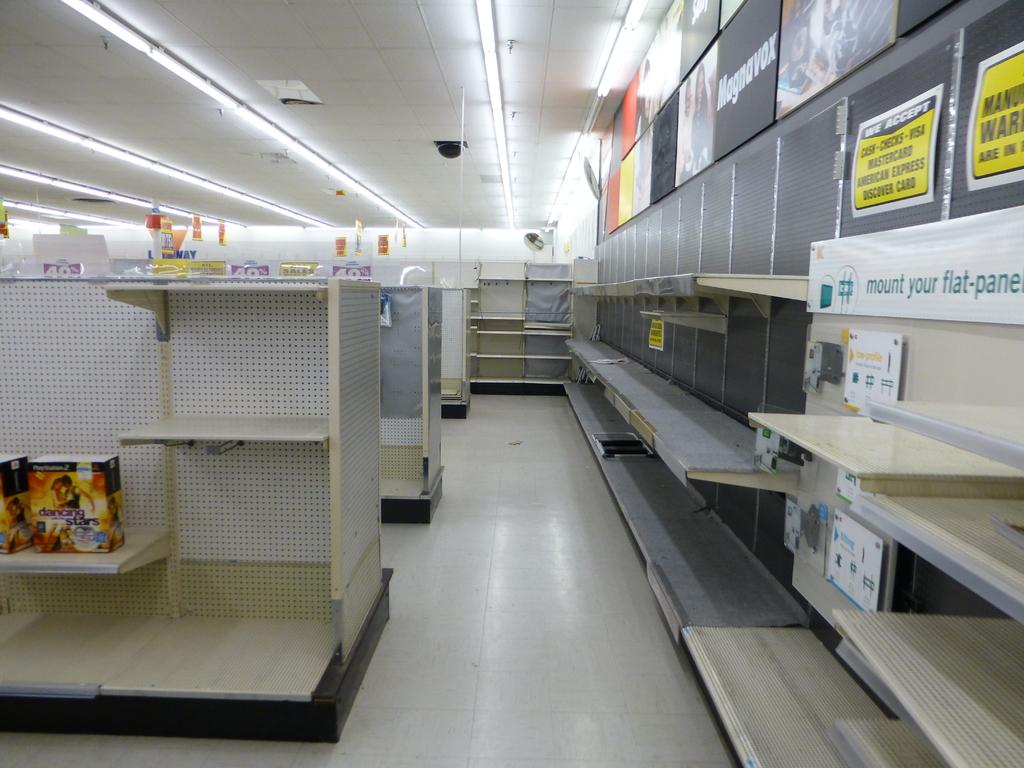<image>
Provide a brief description of the given image. Empty electronics section with a sign that says "mount your flat-panel". 